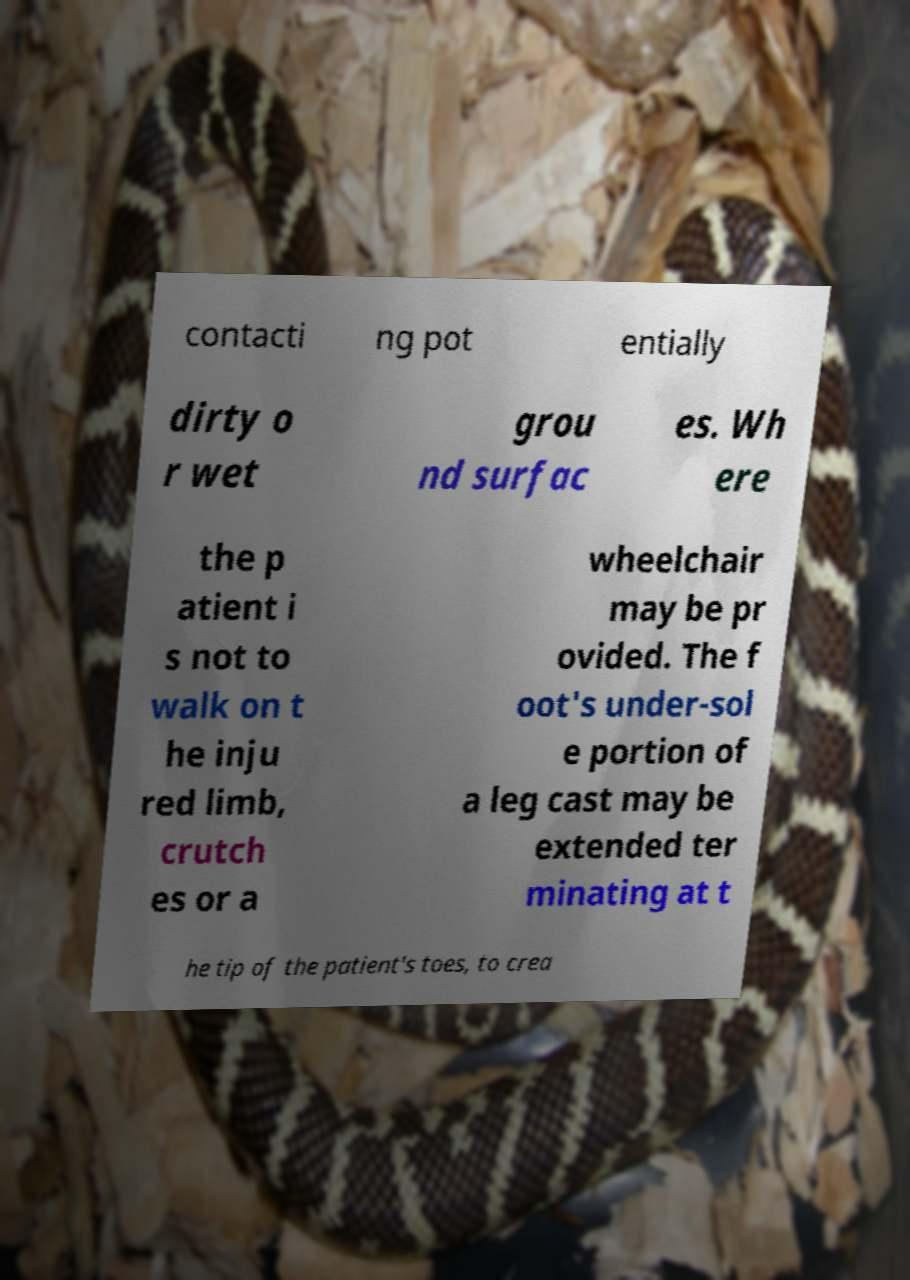Could you extract and type out the text from this image? contacti ng pot entially dirty o r wet grou nd surfac es. Wh ere the p atient i s not to walk on t he inju red limb, crutch es or a wheelchair may be pr ovided. The f oot's under-sol e portion of a leg cast may be extended ter minating at t he tip of the patient's toes, to crea 